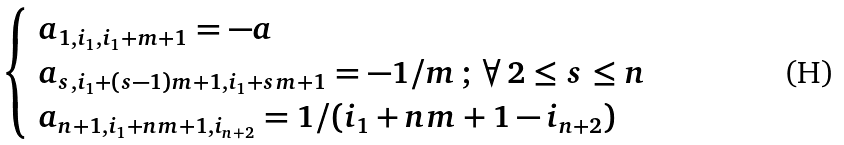Convert formula to latex. <formula><loc_0><loc_0><loc_500><loc_500>\begin{cases} \begin{array} { l c l } a _ { 1 , i _ { 1 } , i _ { 1 } + m + 1 } = - a \\ a _ { s , i _ { 1 } + ( s - 1 ) m + 1 , i _ { 1 } + s m + 1 } = - 1 / m \, ; \, \forall \, 2 \leq s \leq n \\ a _ { n + 1 , i _ { 1 } + n m + 1 , i _ { n + 2 } } = 1 / ( i _ { 1 } + n m + 1 - i _ { n + 2 } ) \end{array} \end{cases}</formula> 